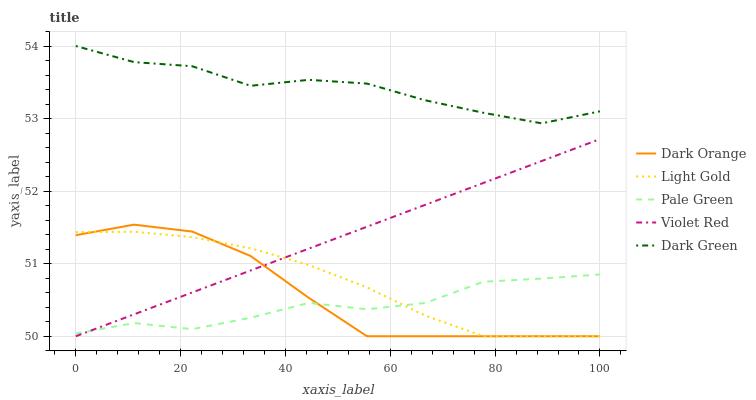Does Violet Red have the minimum area under the curve?
Answer yes or no. No. Does Violet Red have the maximum area under the curve?
Answer yes or no. No. Is Pale Green the smoothest?
Answer yes or no. No. Is Violet Red the roughest?
Answer yes or no. No. Does Pale Green have the lowest value?
Answer yes or no. No. Does Violet Red have the highest value?
Answer yes or no. No. Is Pale Green less than Dark Green?
Answer yes or no. Yes. Is Dark Green greater than Pale Green?
Answer yes or no. Yes. Does Pale Green intersect Dark Green?
Answer yes or no. No. 